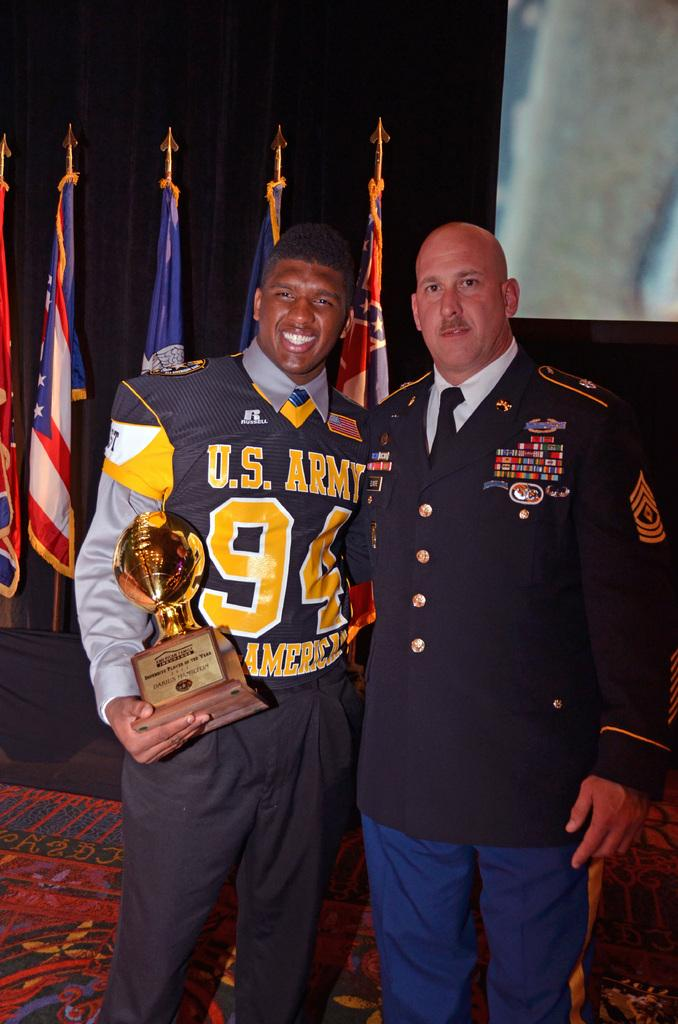Provide a one-sentence caption for the provided image. U.S. Army football player is holding on to an award in the shape of a gold football while standing next to a very decorated military officer. 